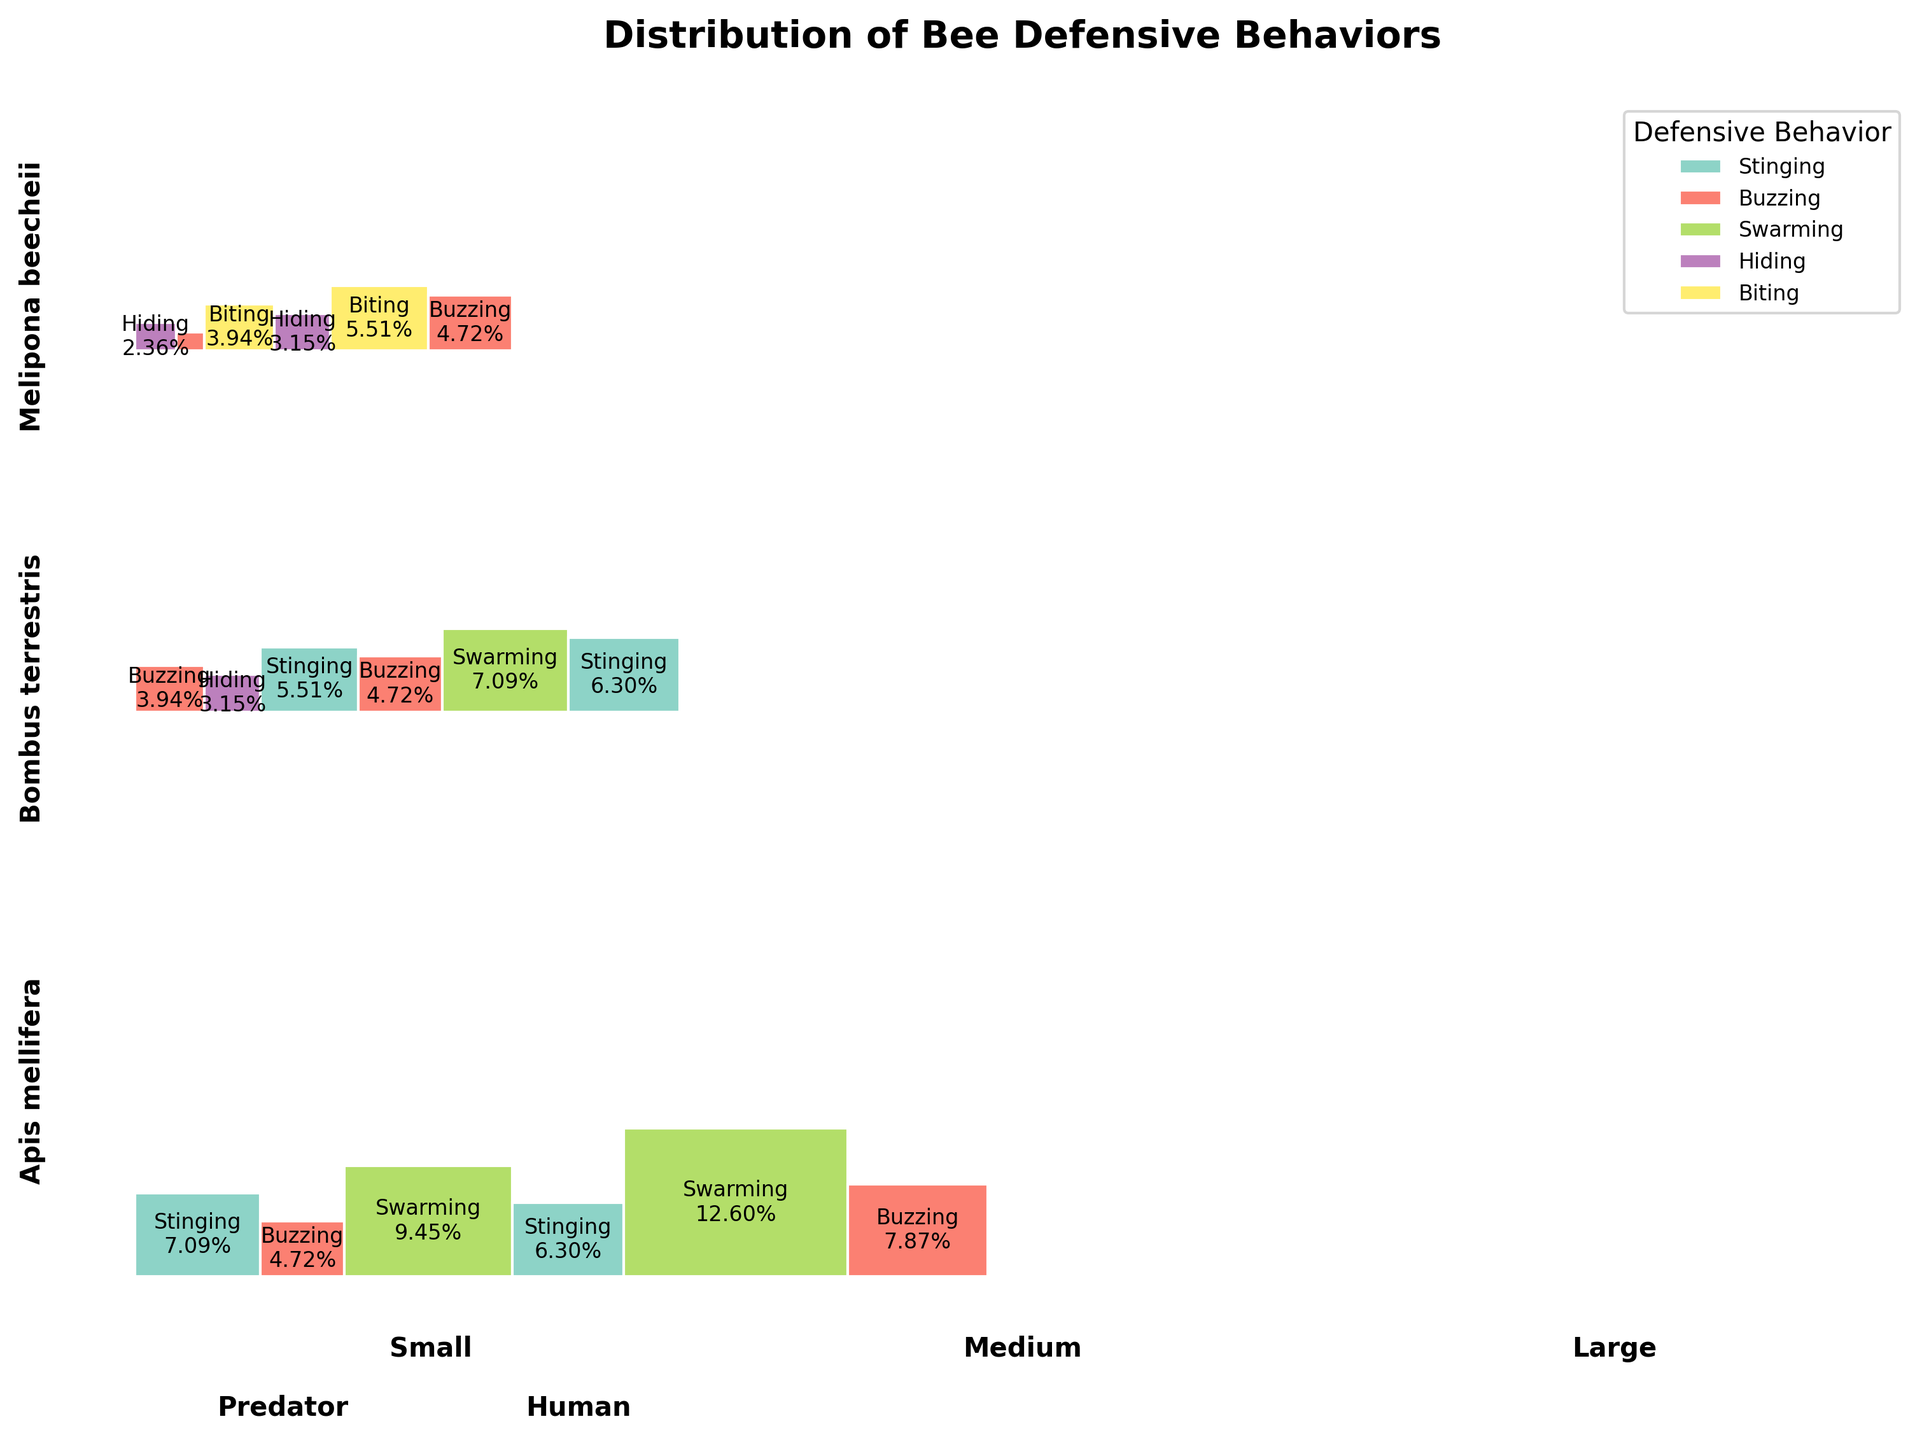What is the most common defensive behavior for Apis mellifera against predators? Look for the largest rectangle under Apis mellifera when a predator is the threat type. The prominent behavior is "Swarming".
Answer: Swarming Which species exhibits the "Hiding" defensive behavior the most? Identify the species with the largest area corresponding to the "Hiding" behavior. Melipona beecheii has the most noticeable area for "Hiding".
Answer: Melipona beecheii What defensive behaviors are observed in Bombus terrestris colonies of small size against humans? Focus on the section for Bombus terrestris with small colony size and human threat. The defensive behaviors are "Buzzing" and "Hiding".
Answer: Buzzing and Hiding How does the behavior distribution in large colonies of Apis mellifera differ when facing human threats compared to predator threats? Compare the large colony sizes of Apis mellifera for human and predator threats. For humans, "Buzzing" is prevalent, and for predators, "Swarming" is predominant.
Answer: Buzzing for humans, Swarming for predators Which colony size of Melipona beecheii reacts more aggressively towards predators? Check the distribution of defensive behaviors for different colony sizes of Melipona beecheii against predators. Large colonies exhibit more "Biting" behavior compared to small and medium colonies.
Answer: Large What is the defensive behavior of medium-sized Bombus terrestris colonies when threatened by humans? Find the section for Bombus terrestris with medium colony size and human threats. The behavior is predominantly "Buzzing".
Answer: Buzzing Which species exhibits the greatest diversity of defensive behaviors? Assess each species' defensive behaviors across different threats and colony sizes. Apis mellifera shows the highest diversity, including "Stinging", "Swarming", and "Buzzing".
Answer: Apis mellifera Is there a defensive behavior that is common across all species when threatened by predators? Analyze each species' reaction to predators. "Swarming" is shared by Apis mellifera and Bombus terrestris, but not by all species. Thus, no single behavior spans all species.
Answer: No What is the predominant defensive behavior of Apis mellifera in medium-sized colonies when threatened by humans? Focus on medium-sized colonies of Apis mellifera under human threats. The behavior is primarily "Stinging".
Answer: Stinging 